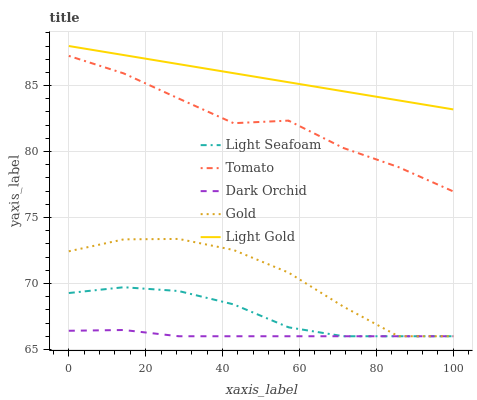Does Dark Orchid have the minimum area under the curve?
Answer yes or no. Yes. Does Light Gold have the maximum area under the curve?
Answer yes or no. Yes. Does Light Seafoam have the minimum area under the curve?
Answer yes or no. No. Does Light Seafoam have the maximum area under the curve?
Answer yes or no. No. Is Light Gold the smoothest?
Answer yes or no. Yes. Is Gold the roughest?
Answer yes or no. Yes. Is Light Seafoam the smoothest?
Answer yes or no. No. Is Light Seafoam the roughest?
Answer yes or no. No. Does Light Seafoam have the lowest value?
Answer yes or no. Yes. Does Light Gold have the lowest value?
Answer yes or no. No. Does Light Gold have the highest value?
Answer yes or no. Yes. Does Light Seafoam have the highest value?
Answer yes or no. No. Is Light Seafoam less than Light Gold?
Answer yes or no. Yes. Is Tomato greater than Light Seafoam?
Answer yes or no. Yes. Does Dark Orchid intersect Light Seafoam?
Answer yes or no. Yes. Is Dark Orchid less than Light Seafoam?
Answer yes or no. No. Is Dark Orchid greater than Light Seafoam?
Answer yes or no. No. Does Light Seafoam intersect Light Gold?
Answer yes or no. No. 